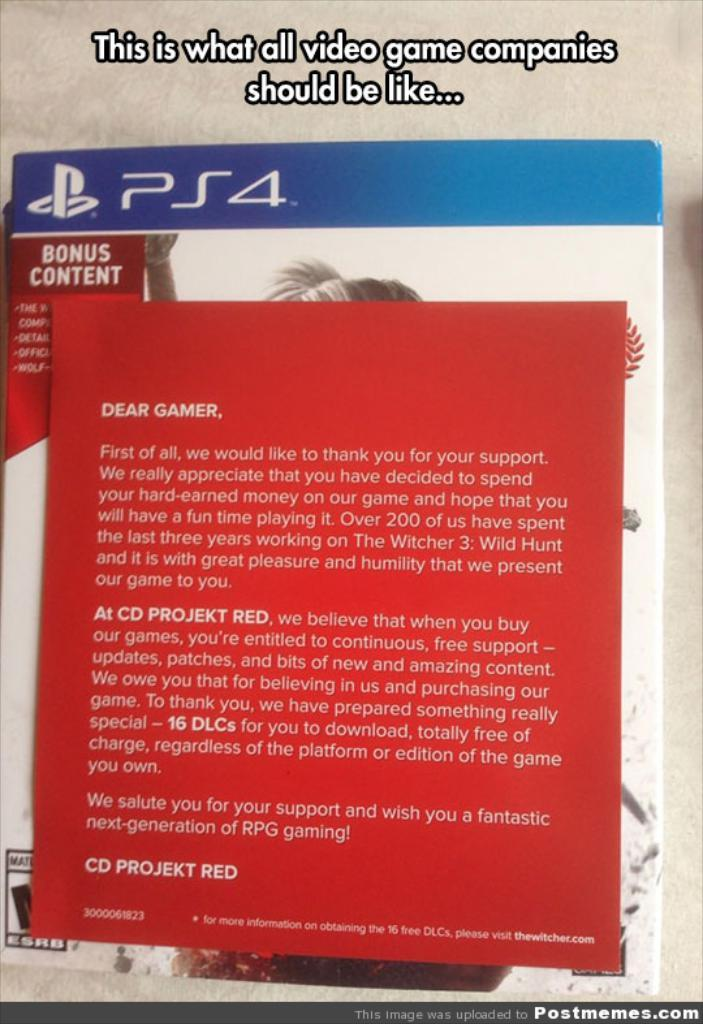<image>
Create a compact narrative representing the image presented. A brochure in a game from company CD PROJEKT RED. 